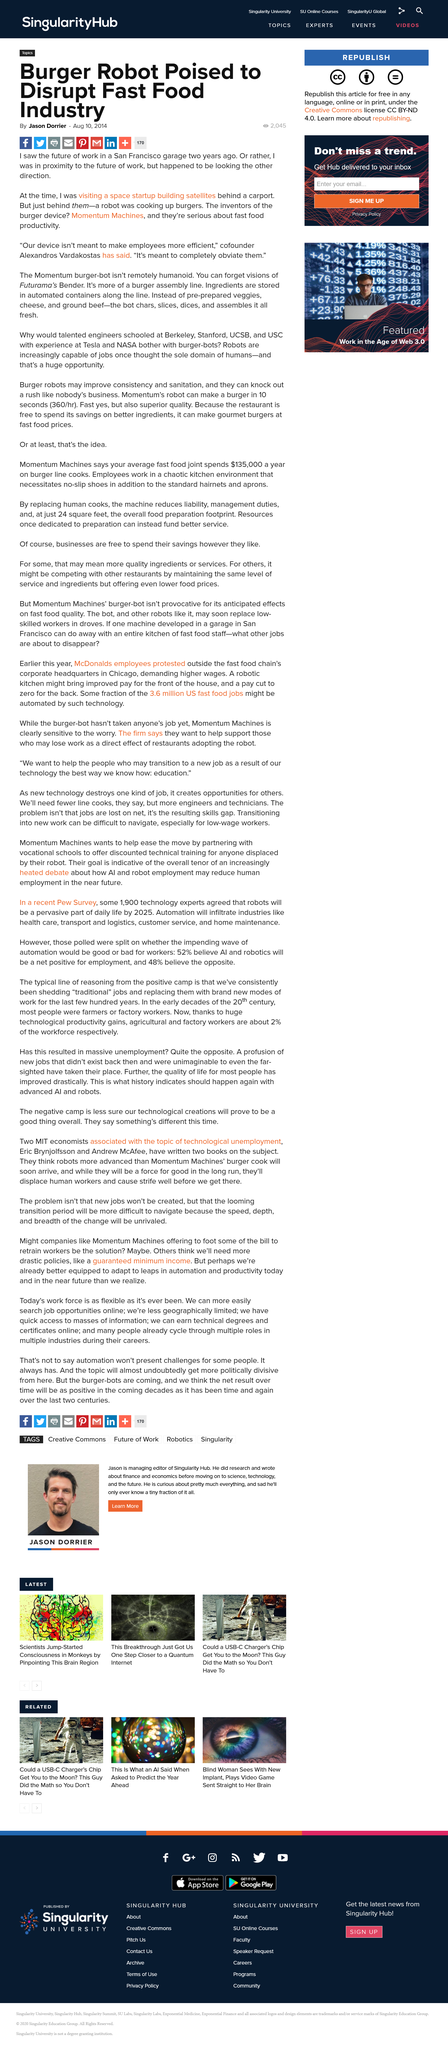Identify some key points in this picture. Ingredients are stored in automated containers along the assembly line, which allows for efficient and accurate storage of materials. Our burger robot, designed to replace human employees, offers numerous benefits to the fast food industry, including increased efficiency and productivity. I declare that the inventors of the burger device are Momentum Machines. 